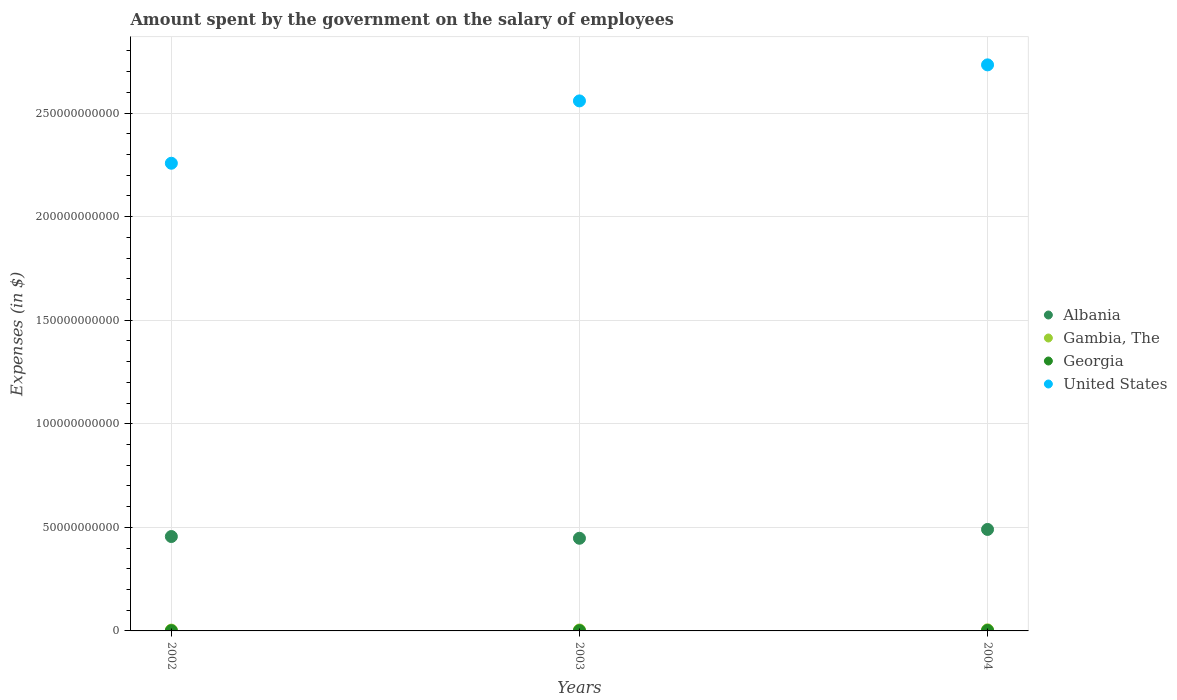How many different coloured dotlines are there?
Your answer should be compact. 4. What is the amount spent on the salary of employees by the government in United States in 2003?
Ensure brevity in your answer.  2.56e+11. Across all years, what is the maximum amount spent on the salary of employees by the government in Georgia?
Make the answer very short. 2.33e+08. Across all years, what is the minimum amount spent on the salary of employees by the government in United States?
Provide a short and direct response. 2.26e+11. What is the total amount spent on the salary of employees by the government in Albania in the graph?
Provide a short and direct response. 1.39e+11. What is the difference between the amount spent on the salary of employees by the government in Gambia, The in 2003 and that in 2004?
Your answer should be very brief. -5.85e+07. What is the difference between the amount spent on the salary of employees by the government in Albania in 2004 and the amount spent on the salary of employees by the government in Georgia in 2003?
Your answer should be very brief. 4.89e+1. What is the average amount spent on the salary of employees by the government in Gambia, The per year?
Give a very brief answer. 4.57e+08. In the year 2004, what is the difference between the amount spent on the salary of employees by the government in Georgia and amount spent on the salary of employees by the government in United States?
Provide a short and direct response. -2.73e+11. In how many years, is the amount spent on the salary of employees by the government in Georgia greater than 100000000000 $?
Make the answer very short. 0. What is the ratio of the amount spent on the salary of employees by the government in United States in 2002 to that in 2003?
Your response must be concise. 0.88. What is the difference between the highest and the second highest amount spent on the salary of employees by the government in Georgia?
Ensure brevity in your answer.  1.02e+08. What is the difference between the highest and the lowest amount spent on the salary of employees by the government in Gambia, The?
Ensure brevity in your answer.  1.22e+08. Is the sum of the amount spent on the salary of employees by the government in Georgia in 2003 and 2004 greater than the maximum amount spent on the salary of employees by the government in Albania across all years?
Ensure brevity in your answer.  No. Is it the case that in every year, the sum of the amount spent on the salary of employees by the government in Gambia, The and amount spent on the salary of employees by the government in Georgia  is greater than the sum of amount spent on the salary of employees by the government in United States and amount spent on the salary of employees by the government in Albania?
Make the answer very short. No. Is the amount spent on the salary of employees by the government in Gambia, The strictly greater than the amount spent on the salary of employees by the government in Albania over the years?
Keep it short and to the point. No. How many dotlines are there?
Your answer should be compact. 4. How many years are there in the graph?
Your answer should be compact. 3. Does the graph contain any zero values?
Keep it short and to the point. No. How many legend labels are there?
Offer a terse response. 4. What is the title of the graph?
Offer a terse response. Amount spent by the government on the salary of employees. Does "Lebanon" appear as one of the legend labels in the graph?
Your response must be concise. No. What is the label or title of the X-axis?
Offer a terse response. Years. What is the label or title of the Y-axis?
Offer a very short reply. Expenses (in $). What is the Expenses (in $) of Albania in 2002?
Make the answer very short. 4.56e+1. What is the Expenses (in $) in Gambia, The in 2002?
Give a very brief answer. 3.95e+08. What is the Expenses (in $) of Georgia in 2002?
Ensure brevity in your answer.  1.12e+08. What is the Expenses (in $) of United States in 2002?
Make the answer very short. 2.26e+11. What is the Expenses (in $) of Albania in 2003?
Your answer should be very brief. 4.47e+1. What is the Expenses (in $) of Gambia, The in 2003?
Offer a terse response. 4.59e+08. What is the Expenses (in $) of Georgia in 2003?
Give a very brief answer. 1.32e+08. What is the Expenses (in $) in United States in 2003?
Give a very brief answer. 2.56e+11. What is the Expenses (in $) in Albania in 2004?
Give a very brief answer. 4.90e+1. What is the Expenses (in $) in Gambia, The in 2004?
Offer a very short reply. 5.18e+08. What is the Expenses (in $) of Georgia in 2004?
Provide a short and direct response. 2.33e+08. What is the Expenses (in $) of United States in 2004?
Provide a succinct answer. 2.73e+11. Across all years, what is the maximum Expenses (in $) in Albania?
Ensure brevity in your answer.  4.90e+1. Across all years, what is the maximum Expenses (in $) in Gambia, The?
Provide a short and direct response. 5.18e+08. Across all years, what is the maximum Expenses (in $) of Georgia?
Your answer should be compact. 2.33e+08. Across all years, what is the maximum Expenses (in $) of United States?
Offer a very short reply. 2.73e+11. Across all years, what is the minimum Expenses (in $) of Albania?
Your answer should be very brief. 4.47e+1. Across all years, what is the minimum Expenses (in $) of Gambia, The?
Offer a very short reply. 3.95e+08. Across all years, what is the minimum Expenses (in $) of Georgia?
Keep it short and to the point. 1.12e+08. Across all years, what is the minimum Expenses (in $) in United States?
Give a very brief answer. 2.26e+11. What is the total Expenses (in $) of Albania in the graph?
Your answer should be compact. 1.39e+11. What is the total Expenses (in $) of Gambia, The in the graph?
Provide a succinct answer. 1.37e+09. What is the total Expenses (in $) in Georgia in the graph?
Offer a very short reply. 4.76e+08. What is the total Expenses (in $) of United States in the graph?
Keep it short and to the point. 7.55e+11. What is the difference between the Expenses (in $) of Albania in 2002 and that in 2003?
Your answer should be very brief. 8.36e+08. What is the difference between the Expenses (in $) in Gambia, The in 2002 and that in 2003?
Your answer should be very brief. -6.40e+07. What is the difference between the Expenses (in $) of Georgia in 2002 and that in 2003?
Make the answer very short. -1.95e+07. What is the difference between the Expenses (in $) in United States in 2002 and that in 2003?
Ensure brevity in your answer.  -3.01e+1. What is the difference between the Expenses (in $) in Albania in 2002 and that in 2004?
Make the answer very short. -3.42e+09. What is the difference between the Expenses (in $) in Gambia, The in 2002 and that in 2004?
Your response must be concise. -1.22e+08. What is the difference between the Expenses (in $) in Georgia in 2002 and that in 2004?
Ensure brevity in your answer.  -1.21e+08. What is the difference between the Expenses (in $) in United States in 2002 and that in 2004?
Make the answer very short. -4.75e+1. What is the difference between the Expenses (in $) in Albania in 2003 and that in 2004?
Give a very brief answer. -4.26e+09. What is the difference between the Expenses (in $) of Gambia, The in 2003 and that in 2004?
Offer a very short reply. -5.85e+07. What is the difference between the Expenses (in $) in Georgia in 2003 and that in 2004?
Provide a succinct answer. -1.02e+08. What is the difference between the Expenses (in $) in United States in 2003 and that in 2004?
Provide a succinct answer. -1.74e+1. What is the difference between the Expenses (in $) in Albania in 2002 and the Expenses (in $) in Gambia, The in 2003?
Your answer should be compact. 4.51e+1. What is the difference between the Expenses (in $) in Albania in 2002 and the Expenses (in $) in Georgia in 2003?
Give a very brief answer. 4.54e+1. What is the difference between the Expenses (in $) in Albania in 2002 and the Expenses (in $) in United States in 2003?
Offer a terse response. -2.10e+11. What is the difference between the Expenses (in $) of Gambia, The in 2002 and the Expenses (in $) of Georgia in 2003?
Provide a succinct answer. 2.64e+08. What is the difference between the Expenses (in $) in Gambia, The in 2002 and the Expenses (in $) in United States in 2003?
Provide a succinct answer. -2.56e+11. What is the difference between the Expenses (in $) of Georgia in 2002 and the Expenses (in $) of United States in 2003?
Your response must be concise. -2.56e+11. What is the difference between the Expenses (in $) of Albania in 2002 and the Expenses (in $) of Gambia, The in 2004?
Make the answer very short. 4.51e+1. What is the difference between the Expenses (in $) of Albania in 2002 and the Expenses (in $) of Georgia in 2004?
Provide a succinct answer. 4.53e+1. What is the difference between the Expenses (in $) of Albania in 2002 and the Expenses (in $) of United States in 2004?
Your answer should be compact. -2.28e+11. What is the difference between the Expenses (in $) of Gambia, The in 2002 and the Expenses (in $) of Georgia in 2004?
Keep it short and to the point. 1.62e+08. What is the difference between the Expenses (in $) of Gambia, The in 2002 and the Expenses (in $) of United States in 2004?
Your answer should be compact. -2.73e+11. What is the difference between the Expenses (in $) in Georgia in 2002 and the Expenses (in $) in United States in 2004?
Give a very brief answer. -2.73e+11. What is the difference between the Expenses (in $) of Albania in 2003 and the Expenses (in $) of Gambia, The in 2004?
Provide a short and direct response. 4.42e+1. What is the difference between the Expenses (in $) in Albania in 2003 and the Expenses (in $) in Georgia in 2004?
Make the answer very short. 4.45e+1. What is the difference between the Expenses (in $) in Albania in 2003 and the Expenses (in $) in United States in 2004?
Give a very brief answer. -2.29e+11. What is the difference between the Expenses (in $) in Gambia, The in 2003 and the Expenses (in $) in Georgia in 2004?
Your answer should be compact. 2.26e+08. What is the difference between the Expenses (in $) in Gambia, The in 2003 and the Expenses (in $) in United States in 2004?
Your response must be concise. -2.73e+11. What is the difference between the Expenses (in $) of Georgia in 2003 and the Expenses (in $) of United States in 2004?
Keep it short and to the point. -2.73e+11. What is the average Expenses (in $) in Albania per year?
Offer a terse response. 4.64e+1. What is the average Expenses (in $) of Gambia, The per year?
Provide a succinct answer. 4.57e+08. What is the average Expenses (in $) of Georgia per year?
Your response must be concise. 1.59e+08. What is the average Expenses (in $) of United States per year?
Give a very brief answer. 2.52e+11. In the year 2002, what is the difference between the Expenses (in $) in Albania and Expenses (in $) in Gambia, The?
Provide a succinct answer. 4.52e+1. In the year 2002, what is the difference between the Expenses (in $) in Albania and Expenses (in $) in Georgia?
Your answer should be compact. 4.55e+1. In the year 2002, what is the difference between the Expenses (in $) in Albania and Expenses (in $) in United States?
Keep it short and to the point. -1.80e+11. In the year 2002, what is the difference between the Expenses (in $) of Gambia, The and Expenses (in $) of Georgia?
Offer a terse response. 2.83e+08. In the year 2002, what is the difference between the Expenses (in $) of Gambia, The and Expenses (in $) of United States?
Keep it short and to the point. -2.25e+11. In the year 2002, what is the difference between the Expenses (in $) in Georgia and Expenses (in $) in United States?
Offer a terse response. -2.26e+11. In the year 2003, what is the difference between the Expenses (in $) of Albania and Expenses (in $) of Gambia, The?
Make the answer very short. 4.43e+1. In the year 2003, what is the difference between the Expenses (in $) of Albania and Expenses (in $) of Georgia?
Your response must be concise. 4.46e+1. In the year 2003, what is the difference between the Expenses (in $) of Albania and Expenses (in $) of United States?
Offer a terse response. -2.11e+11. In the year 2003, what is the difference between the Expenses (in $) of Gambia, The and Expenses (in $) of Georgia?
Ensure brevity in your answer.  3.28e+08. In the year 2003, what is the difference between the Expenses (in $) of Gambia, The and Expenses (in $) of United States?
Keep it short and to the point. -2.55e+11. In the year 2003, what is the difference between the Expenses (in $) in Georgia and Expenses (in $) in United States?
Your answer should be very brief. -2.56e+11. In the year 2004, what is the difference between the Expenses (in $) of Albania and Expenses (in $) of Gambia, The?
Offer a very short reply. 4.85e+1. In the year 2004, what is the difference between the Expenses (in $) of Albania and Expenses (in $) of Georgia?
Your answer should be very brief. 4.88e+1. In the year 2004, what is the difference between the Expenses (in $) of Albania and Expenses (in $) of United States?
Offer a terse response. -2.24e+11. In the year 2004, what is the difference between the Expenses (in $) in Gambia, The and Expenses (in $) in Georgia?
Provide a short and direct response. 2.85e+08. In the year 2004, what is the difference between the Expenses (in $) in Gambia, The and Expenses (in $) in United States?
Offer a terse response. -2.73e+11. In the year 2004, what is the difference between the Expenses (in $) of Georgia and Expenses (in $) of United States?
Your answer should be very brief. -2.73e+11. What is the ratio of the Expenses (in $) in Albania in 2002 to that in 2003?
Offer a terse response. 1.02. What is the ratio of the Expenses (in $) of Gambia, The in 2002 to that in 2003?
Make the answer very short. 0.86. What is the ratio of the Expenses (in $) of Georgia in 2002 to that in 2003?
Make the answer very short. 0.85. What is the ratio of the Expenses (in $) of United States in 2002 to that in 2003?
Provide a succinct answer. 0.88. What is the ratio of the Expenses (in $) of Albania in 2002 to that in 2004?
Provide a short and direct response. 0.93. What is the ratio of the Expenses (in $) of Gambia, The in 2002 to that in 2004?
Provide a short and direct response. 0.76. What is the ratio of the Expenses (in $) in Georgia in 2002 to that in 2004?
Your response must be concise. 0.48. What is the ratio of the Expenses (in $) of United States in 2002 to that in 2004?
Give a very brief answer. 0.83. What is the ratio of the Expenses (in $) in Gambia, The in 2003 to that in 2004?
Your response must be concise. 0.89. What is the ratio of the Expenses (in $) of Georgia in 2003 to that in 2004?
Offer a very short reply. 0.56. What is the ratio of the Expenses (in $) of United States in 2003 to that in 2004?
Offer a very short reply. 0.94. What is the difference between the highest and the second highest Expenses (in $) of Albania?
Provide a short and direct response. 3.42e+09. What is the difference between the highest and the second highest Expenses (in $) of Gambia, The?
Offer a terse response. 5.85e+07. What is the difference between the highest and the second highest Expenses (in $) in Georgia?
Ensure brevity in your answer.  1.02e+08. What is the difference between the highest and the second highest Expenses (in $) of United States?
Ensure brevity in your answer.  1.74e+1. What is the difference between the highest and the lowest Expenses (in $) in Albania?
Provide a short and direct response. 4.26e+09. What is the difference between the highest and the lowest Expenses (in $) in Gambia, The?
Your answer should be compact. 1.22e+08. What is the difference between the highest and the lowest Expenses (in $) in Georgia?
Your answer should be very brief. 1.21e+08. What is the difference between the highest and the lowest Expenses (in $) of United States?
Keep it short and to the point. 4.75e+1. 